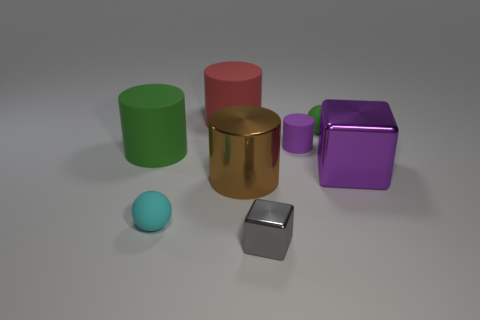How many objects are either tiny matte balls that are behind the small cyan object or green objects to the right of the metal cylinder?
Offer a terse response. 1. What material is the other object that is the same shape as the cyan object?
Make the answer very short. Rubber. How many metal objects are purple things or green objects?
Your answer should be compact. 1. What is the shape of the small green thing that is made of the same material as the tiny purple cylinder?
Provide a short and direct response. Sphere. How many other big things have the same shape as the large green object?
Offer a terse response. 2. Is the shape of the small thing that is to the left of the red object the same as the metal object in front of the cyan matte sphere?
Offer a terse response. No. How many objects are large purple blocks or green things that are in front of the small purple cylinder?
Your answer should be compact. 2. The small thing that is the same color as the large shiny block is what shape?
Your response must be concise. Cylinder. How many brown matte things have the same size as the red object?
Your answer should be very brief. 0. How many red objects are tiny balls or large shiny blocks?
Ensure brevity in your answer.  0. 